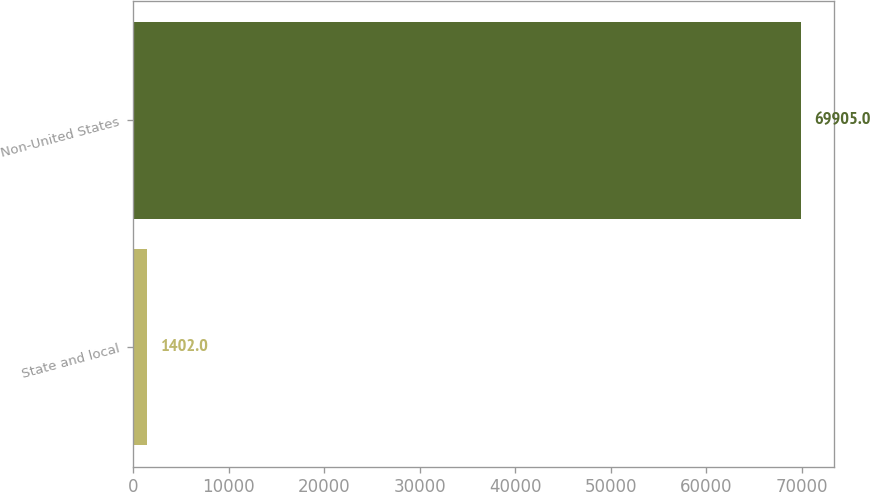Convert chart. <chart><loc_0><loc_0><loc_500><loc_500><bar_chart><fcel>State and local<fcel>Non-United States<nl><fcel>1402<fcel>69905<nl></chart> 